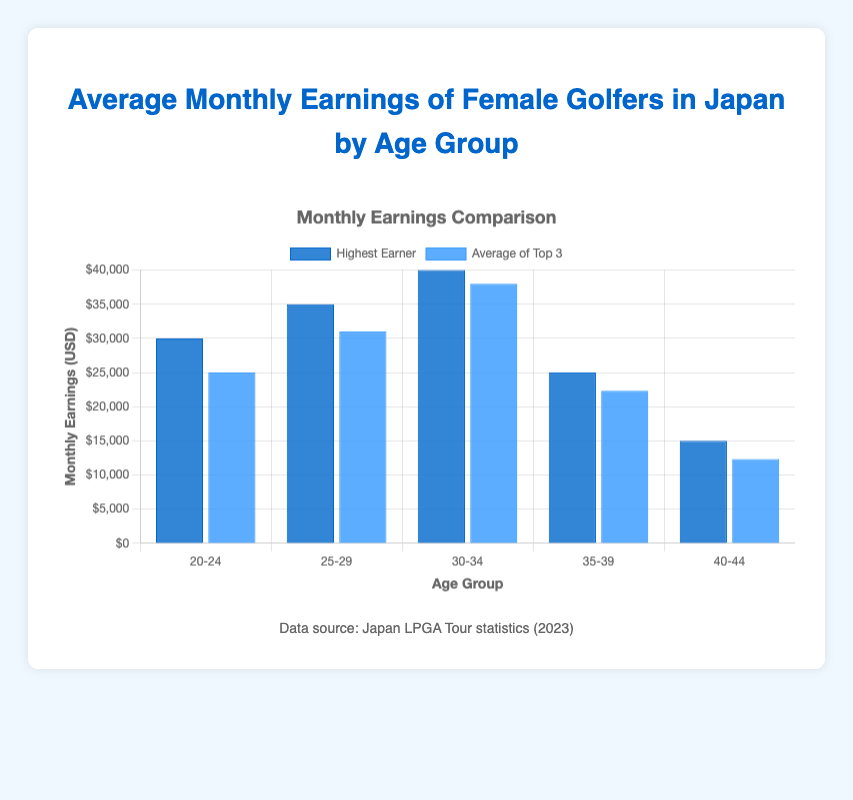Which age group has the highest average monthly earnings for the top 3 golfers? To find the age group with the highest average monthly earnings for the top 3 golfers, look at the light blue bars representing "Average of Top 3". The highest bar in this grouping is the one labeled "30-34".
Answer: 30-34 How much more do golfers aged 25-29 make on average compared to those aged 40-44? Find the "Average of Top 3" values for age groups 25-29 and 40-44. For 25-29, it is $31,000. For 40-44, it is $12,333. Subtract $12,333 from $31,000 to get the difference.
Answer: $18,667 Which age group has the lowest earnings among the "Highest Earner" category? To determine the age group with the lowest "Highest Earner" earnings, check the dark blue bars. The lowest bar is for the age group "40-44" with earnings of $15,000.
Answer: 40-44 What is the visual difference between the "Highest Earner" and "Average of Top 3" for the age group 20-24? Compare the height of the dark blue bar (Highest Earner) with the light blue bar (Average of Top 3) within the 20-24 age group. The dark blue bar reaches $30,000, while the light blue bar reaches $25,000. The visual difference is that the dark blue bar is taller by $5,000.
Answer: $5,000 Is there any age group where the average of the top 3 earnings is higher than the highest earner? Compare the height of light blue bars (Average of Top 3) with dark blue bars (Highest Earner) across all age groups. There is no age group where the light blue bar is higher than the dark blue bar.
Answer: No By how much do the monthly earnings of the highest earner in the 30-34 age group exceed those of the highest earner in the 20-24 age group? Look at the dark blue bars for 30-34 and 20-24. The 30-34 age group's highest earner makes $40,000, and the 20-24 age group's highest earner makes $30,000. Subtract $30,000 from $40,000 to get the difference.
Answer: $10,000 What is the total average monthly earnings of the top 3 golfers in the age groups 25-29 and 35-39 combined? Add the "Average of Top 3" for the age groups. For 25-29, it is $31,000. For 35-39, it is $22,333. The sum is $31,000 + $22,333 = $53,333.
Answer: $53,333 